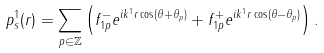Convert formula to latex. <formula><loc_0><loc_0><loc_500><loc_500>p _ { s } ^ { 1 } ( r ) = \sum _ { p \in \mathbb { Z } } \left ( f _ { 1 p } ^ { - } e ^ { i k ^ { 1 } r \cos ( \theta + \theta _ { p } ) } + f _ { 1 p } ^ { + } e ^ { i k ^ { 1 } r \cos ( \theta - \theta _ { p } ) } \right ) .</formula> 